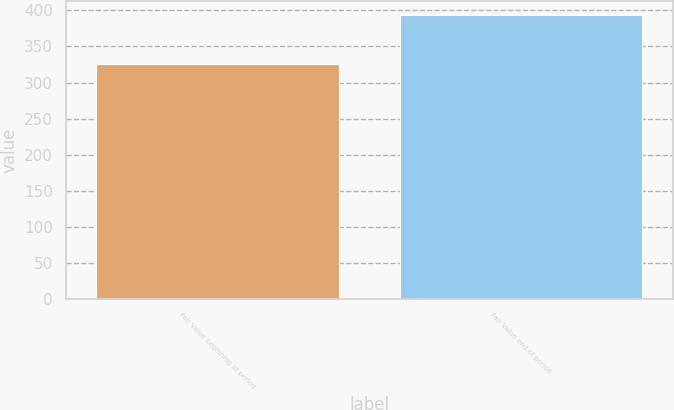Convert chart to OTSL. <chart><loc_0><loc_0><loc_500><loc_500><bar_chart><fcel>Fair Value beginning of period<fcel>Fair Value end of period<nl><fcel>325<fcel>393<nl></chart> 